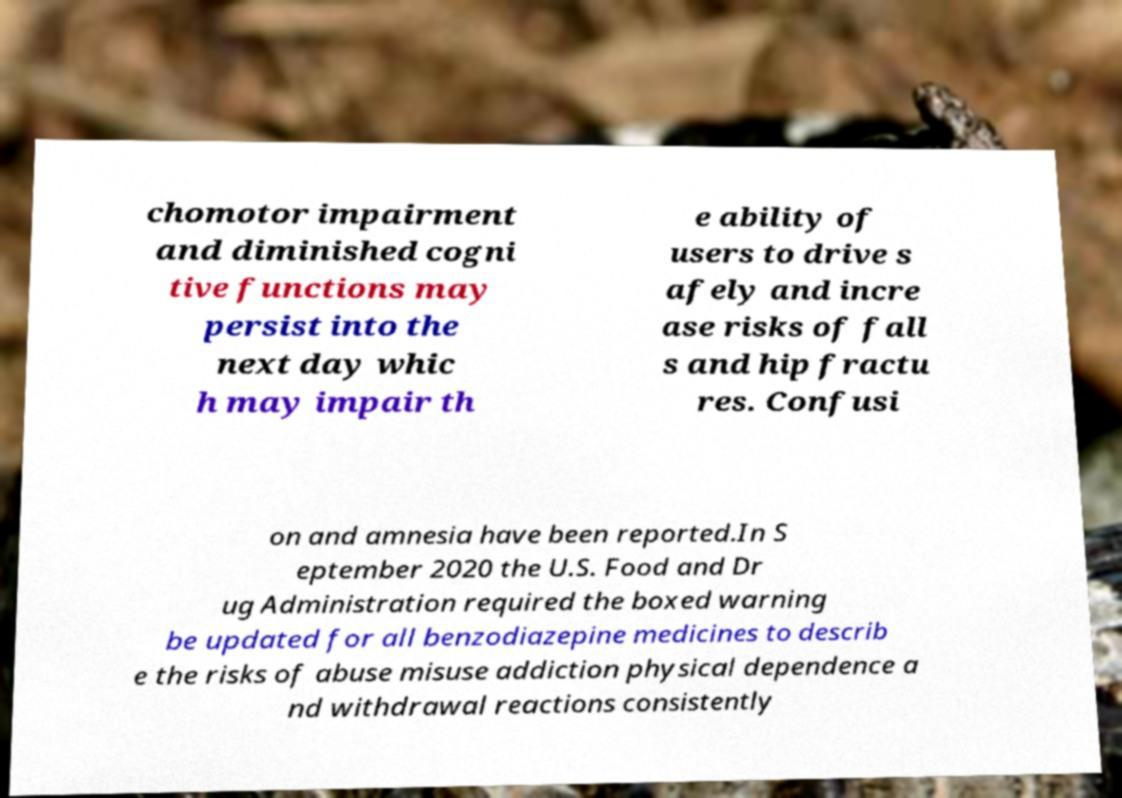For documentation purposes, I need the text within this image transcribed. Could you provide that? chomotor impairment and diminished cogni tive functions may persist into the next day whic h may impair th e ability of users to drive s afely and incre ase risks of fall s and hip fractu res. Confusi on and amnesia have been reported.In S eptember 2020 the U.S. Food and Dr ug Administration required the boxed warning be updated for all benzodiazepine medicines to describ e the risks of abuse misuse addiction physical dependence a nd withdrawal reactions consistently 